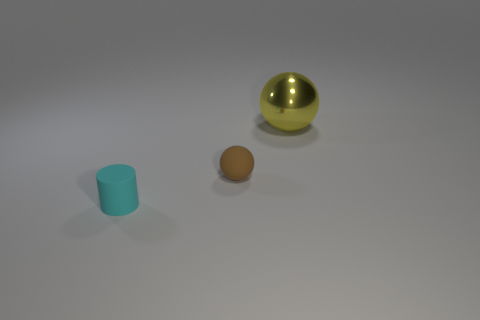There is a small object right of the tiny cyan cylinder; is it the same shape as the rubber thing in front of the matte sphere?
Keep it short and to the point. No. How many other things are there of the same color as the metal sphere?
Make the answer very short. 0. Do the matte thing that is right of the cyan object and the tiny cyan rubber cylinder have the same size?
Your response must be concise. Yes. Is the material of the small thing that is behind the cylinder the same as the big yellow object on the right side of the cyan matte cylinder?
Provide a succinct answer. No. Is there a yellow shiny ball of the same size as the yellow object?
Your response must be concise. No. The matte thing that is behind the tiny matte thing on the left side of the matte thing that is behind the tiny cyan cylinder is what shape?
Your answer should be compact. Sphere. Is the number of large shiny spheres that are left of the yellow ball greater than the number of small cylinders?
Your response must be concise. No. Are there any other small brown metallic objects of the same shape as the brown thing?
Provide a succinct answer. No. Does the cylinder have the same material as the object to the right of the brown ball?
Your response must be concise. No. The big metal sphere is what color?
Your answer should be very brief. Yellow. 